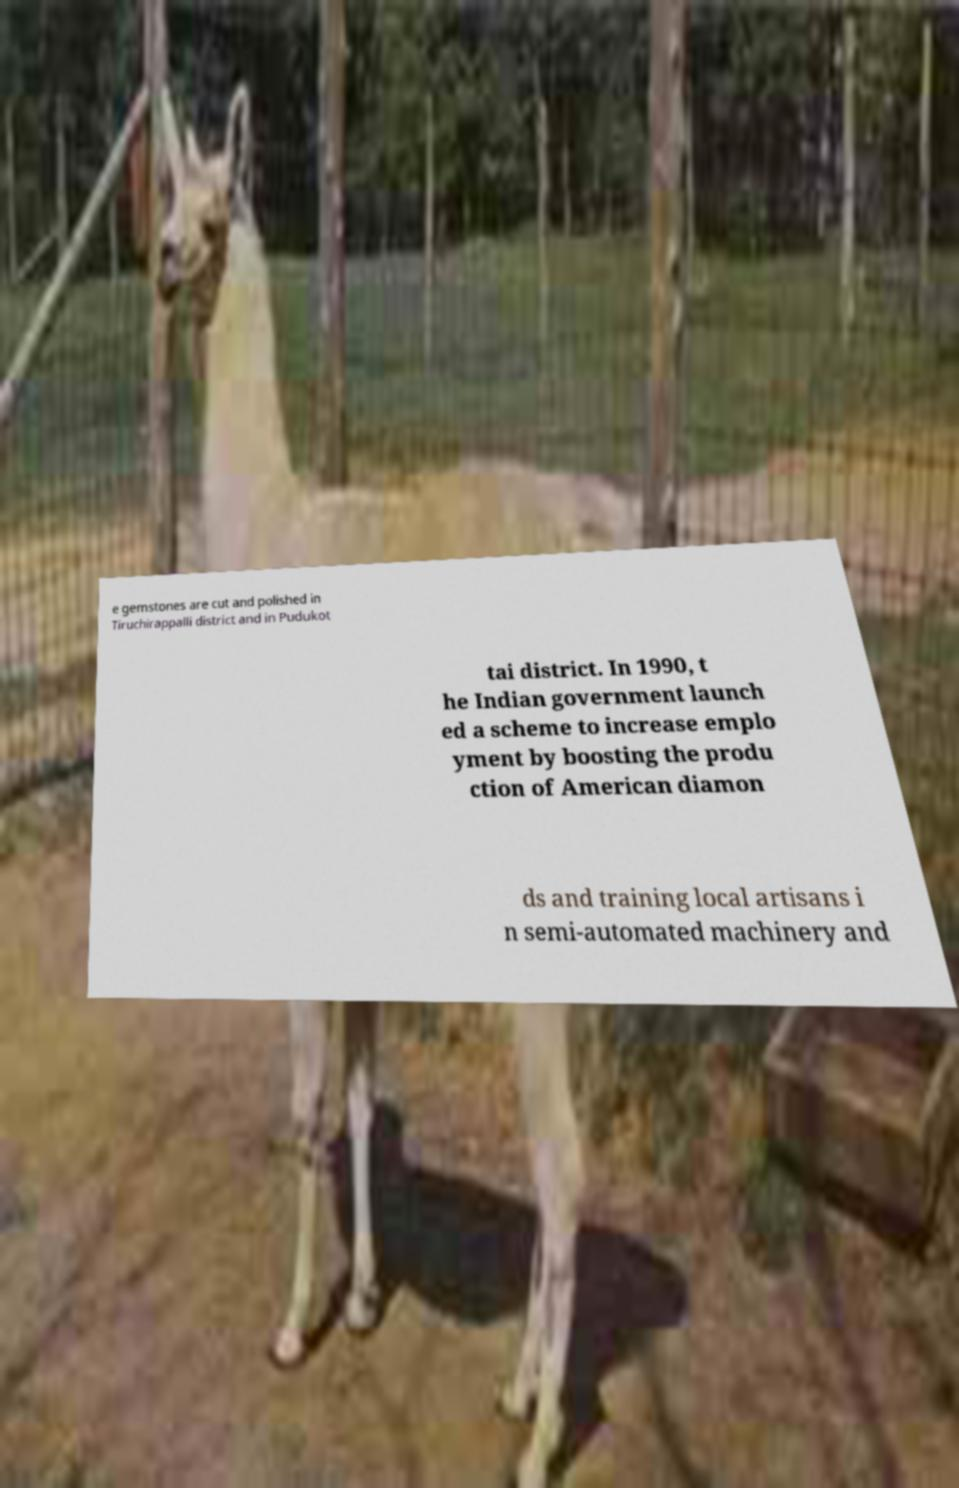Please identify and transcribe the text found in this image. e gemstones are cut and polished in Tiruchirappalli district and in Pudukot tai district. In 1990, t he Indian government launch ed a scheme to increase emplo yment by boosting the produ ction of American diamon ds and training local artisans i n semi-automated machinery and 